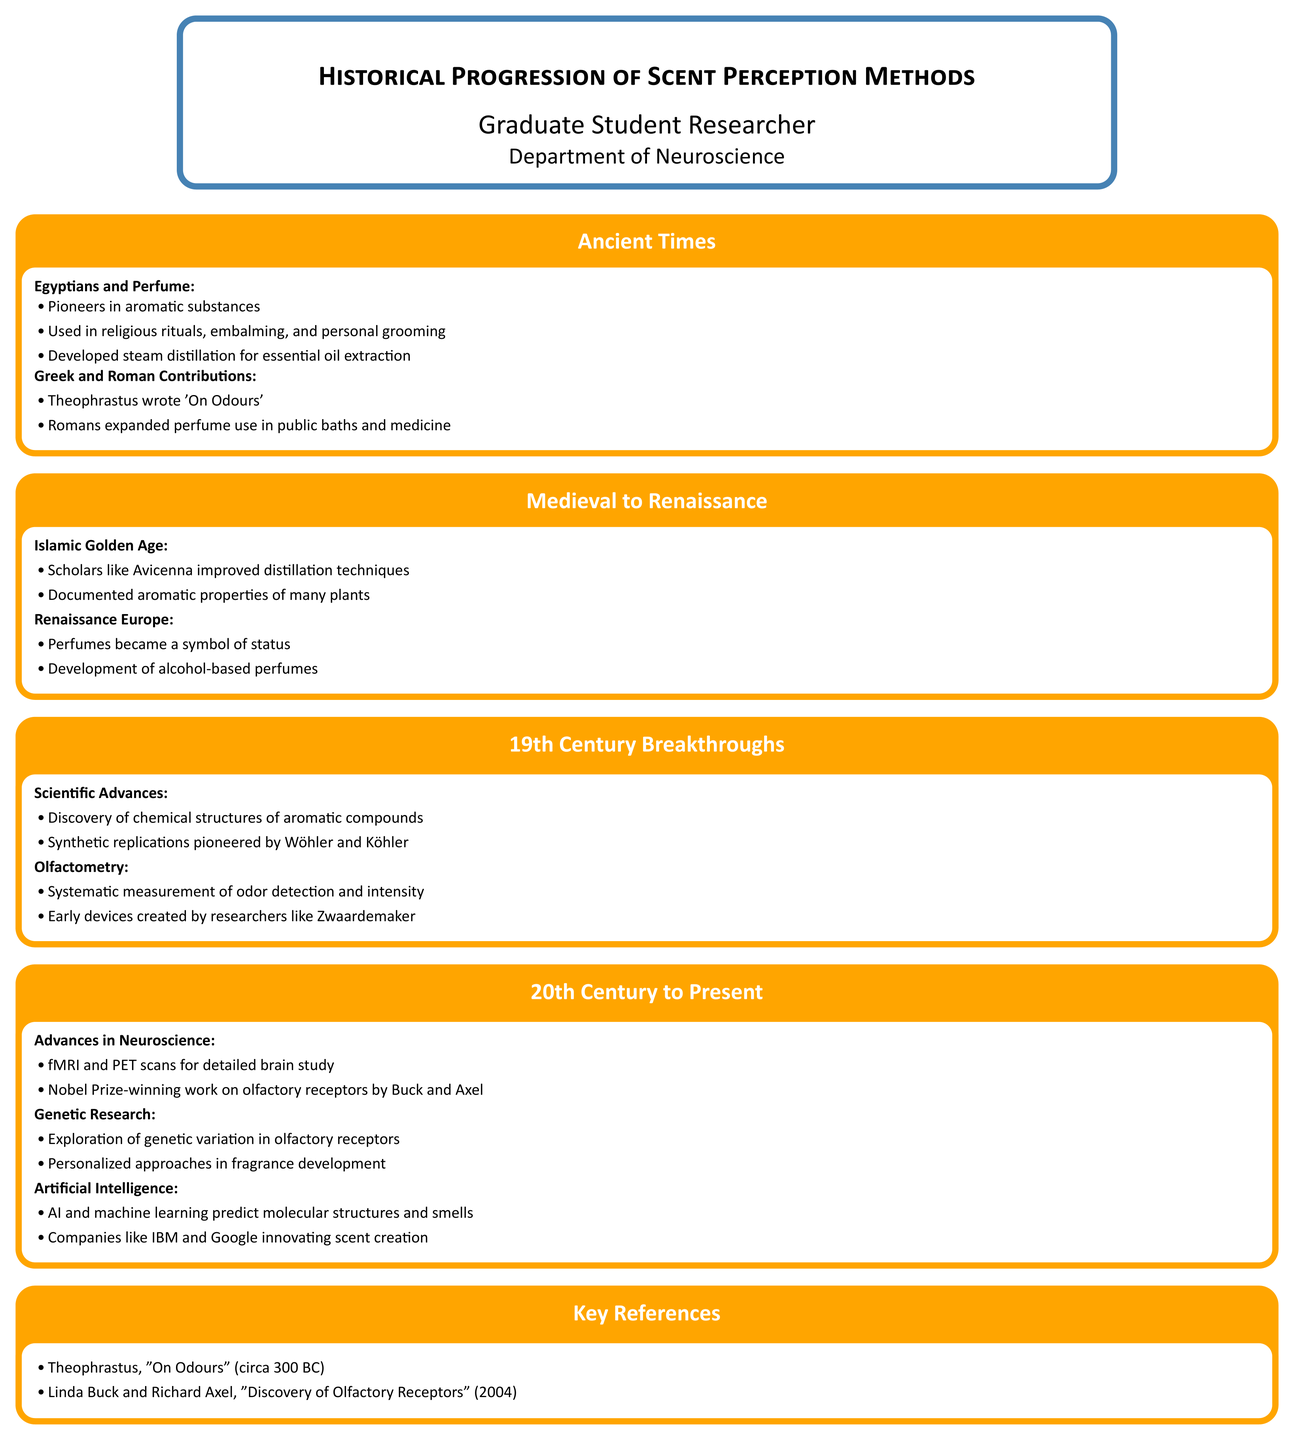What was one use of aromatic substances by the Egyptians? Egyptians used aromatic substances in religious rituals, embalming, and personal grooming.
Answer: Religious rituals Who wrote 'On Odours'? Theophrastus is credited with writing 'On Odours'.
Answer: Theophrastus What significant method did Islamic scholars improve during the Islamic Golden Age? Scholars like Avicenna improved distillation techniques.
Answer: Distillation techniques Which type of perfumes became a symbol of status during the Renaissance in Europe? Alcohol-based perfumes became a symbol of status.
Answer: Alcohol-based perfumes What scientific advancement in the 19th century was significant for olfactometry? Systematic measurement of odor detection and intensity was a significant advancement.
Answer: Systematic measurement Who were awarded the Nobel Prize for their work on olfactory receptors? Linda Buck and Richard Axel received the Nobel Prize for their work.
Answer: Buck and Axel What modern technology is used to predict molecular structures and smells? AI and machine learning are used to predict molecular structures and smells.
Answer: AI and machine learning 